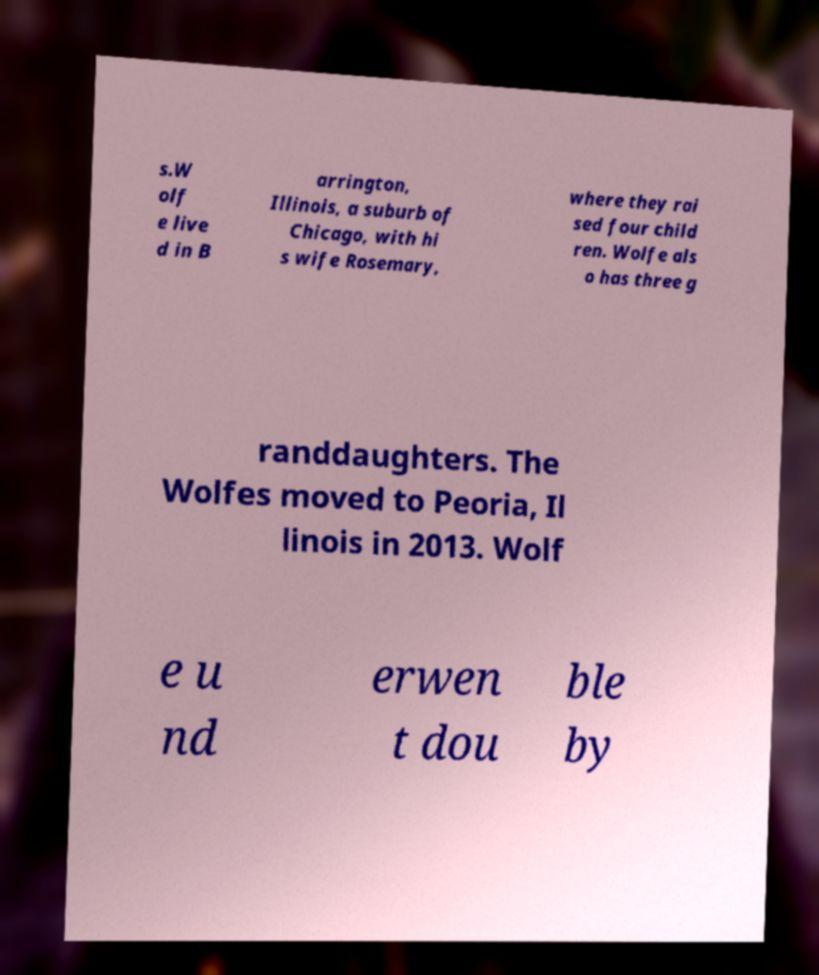For documentation purposes, I need the text within this image transcribed. Could you provide that? s.W olf e live d in B arrington, Illinois, a suburb of Chicago, with hi s wife Rosemary, where they rai sed four child ren. Wolfe als o has three g randdaughters. The Wolfes moved to Peoria, Il linois in 2013. Wolf e u nd erwen t dou ble by 